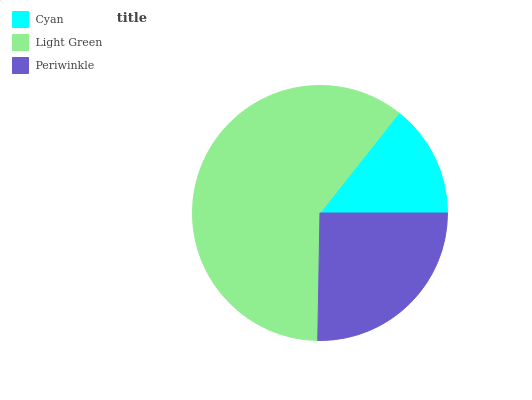Is Cyan the minimum?
Answer yes or no. Yes. Is Light Green the maximum?
Answer yes or no. Yes. Is Periwinkle the minimum?
Answer yes or no. No. Is Periwinkle the maximum?
Answer yes or no. No. Is Light Green greater than Periwinkle?
Answer yes or no. Yes. Is Periwinkle less than Light Green?
Answer yes or no. Yes. Is Periwinkle greater than Light Green?
Answer yes or no. No. Is Light Green less than Periwinkle?
Answer yes or no. No. Is Periwinkle the high median?
Answer yes or no. Yes. Is Periwinkle the low median?
Answer yes or no. Yes. Is Cyan the high median?
Answer yes or no. No. Is Cyan the low median?
Answer yes or no. No. 